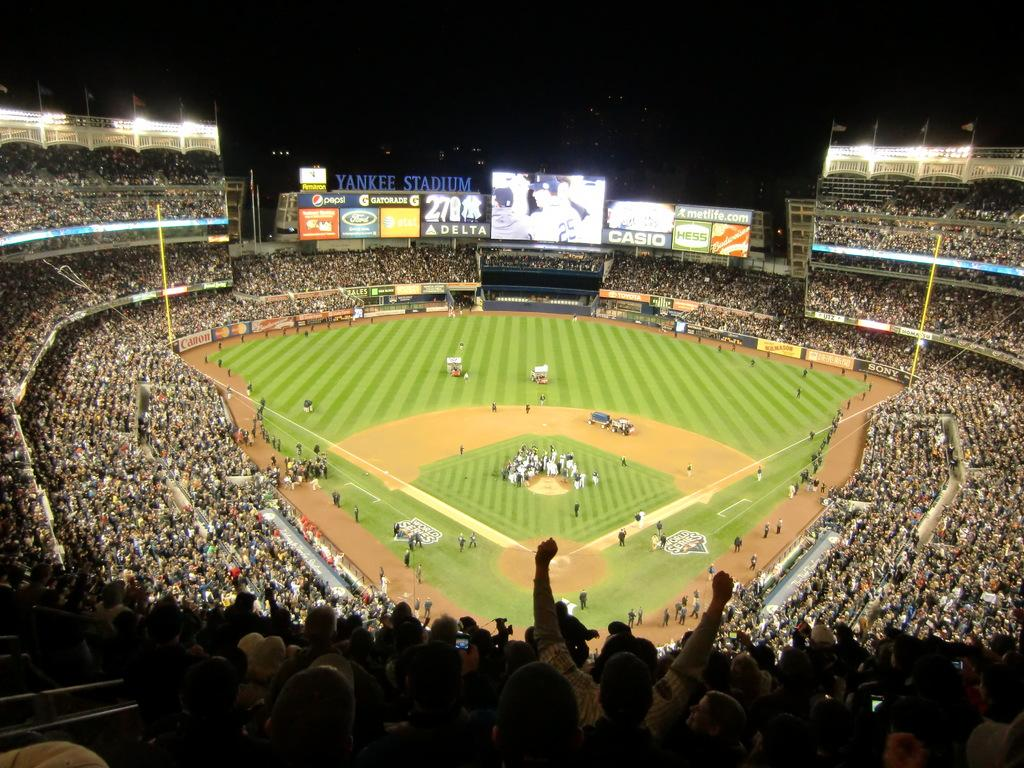<image>
Present a compact description of the photo's key features. Baseball stadium that shows an ad for CASIO. 